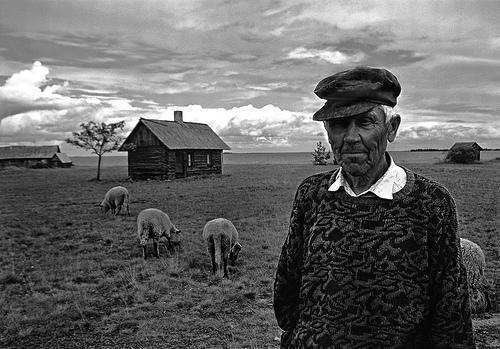What color is the shirt underneath of the old man's sweater?
Answer the question by selecting the correct answer among the 4 following choices.
Options: Black, white, green, red. White. 